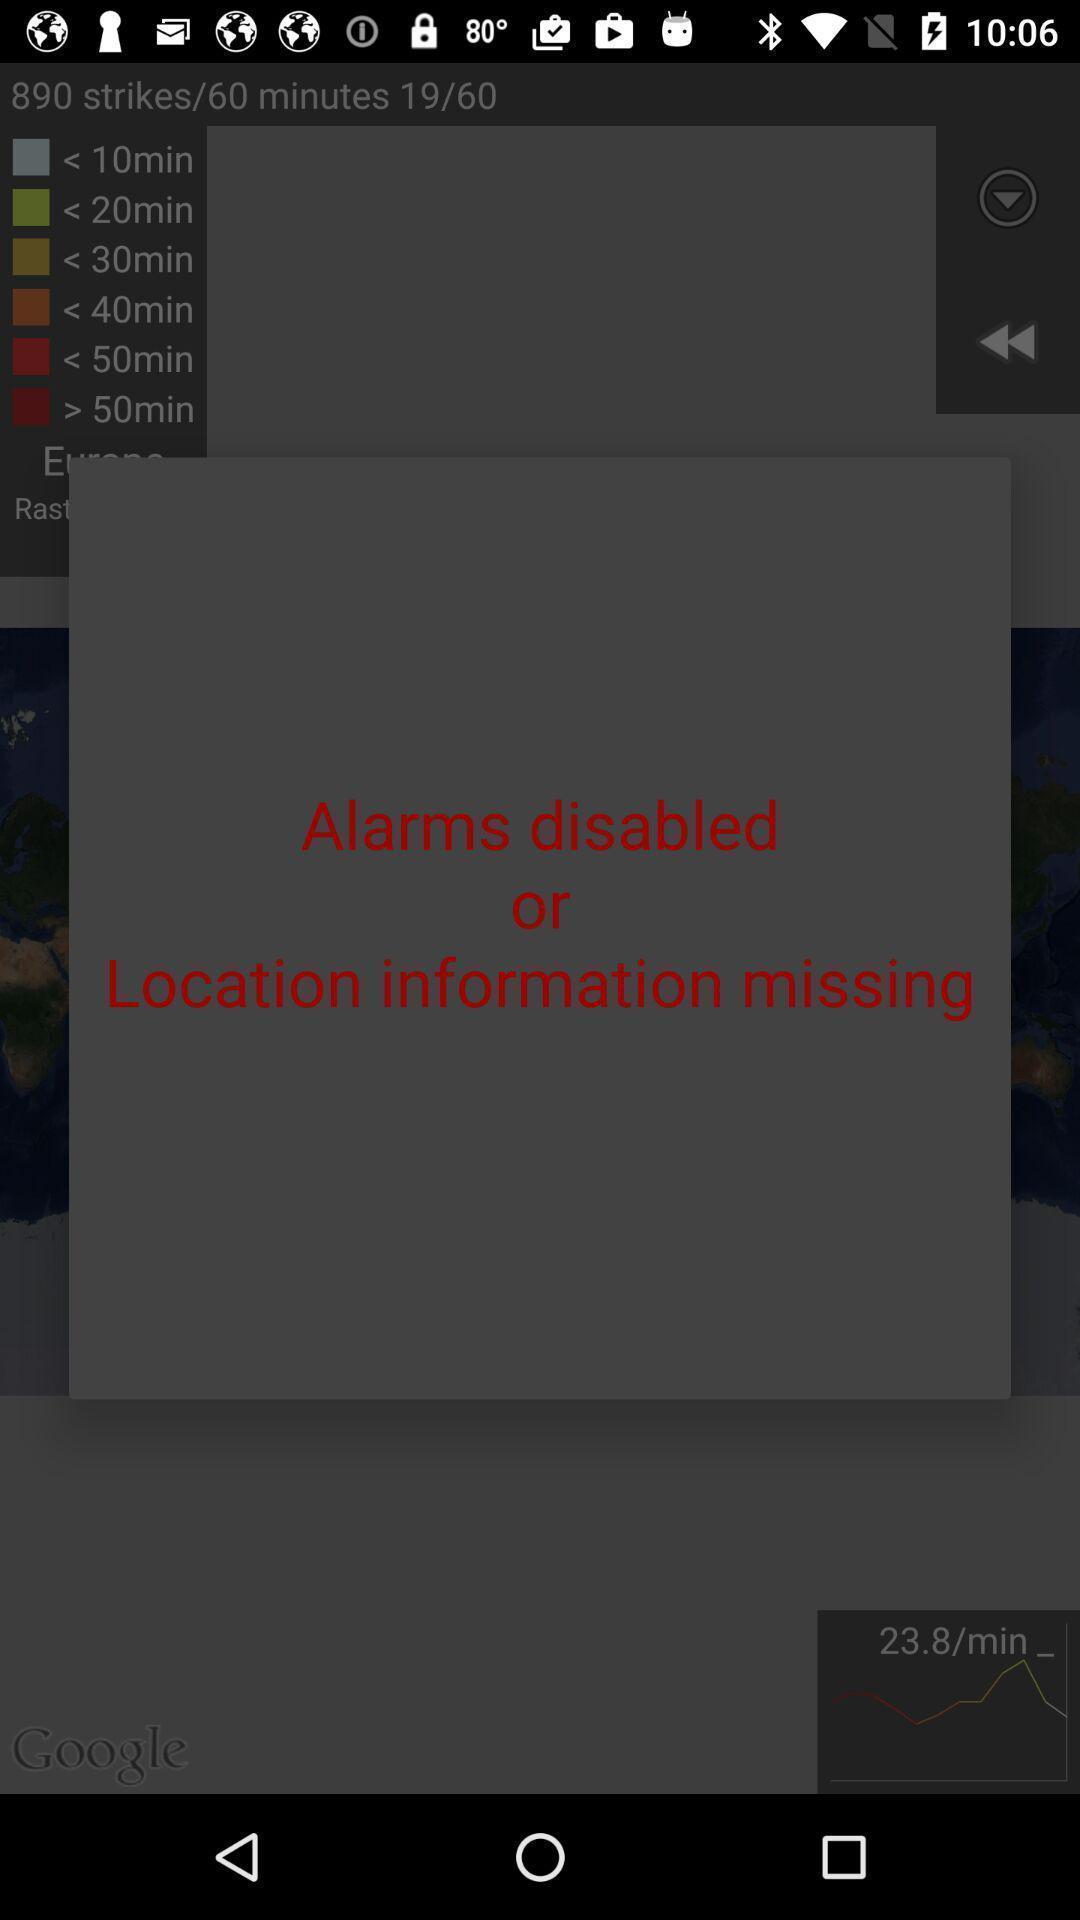Provide a description of this screenshot. Warning text regarding missing thing in application. 